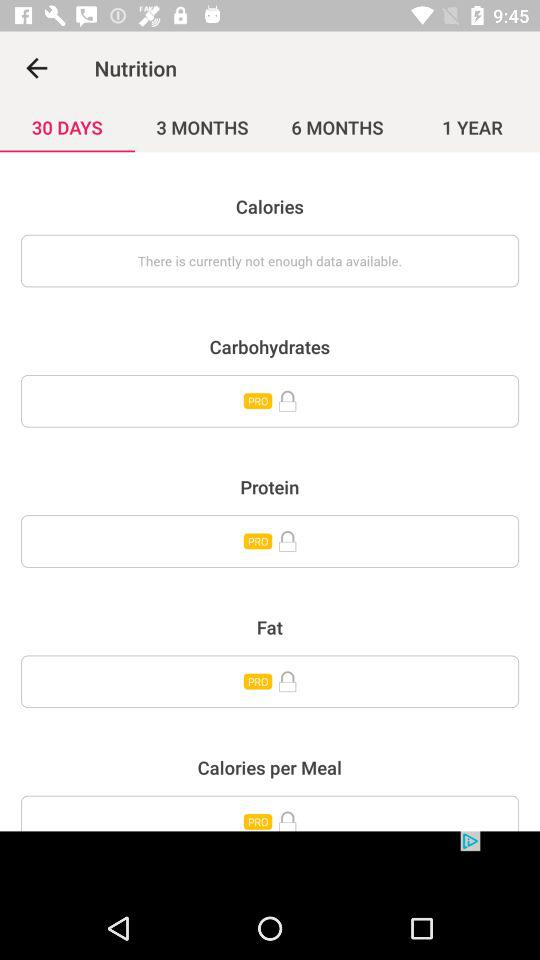Which tab is selected? The selected tab is "30 DAYS". 